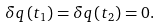<formula> <loc_0><loc_0><loc_500><loc_500>\delta q \left ( t _ { 1 } \right ) = \delta q \left ( t _ { 2 } \right ) = 0 .</formula> 